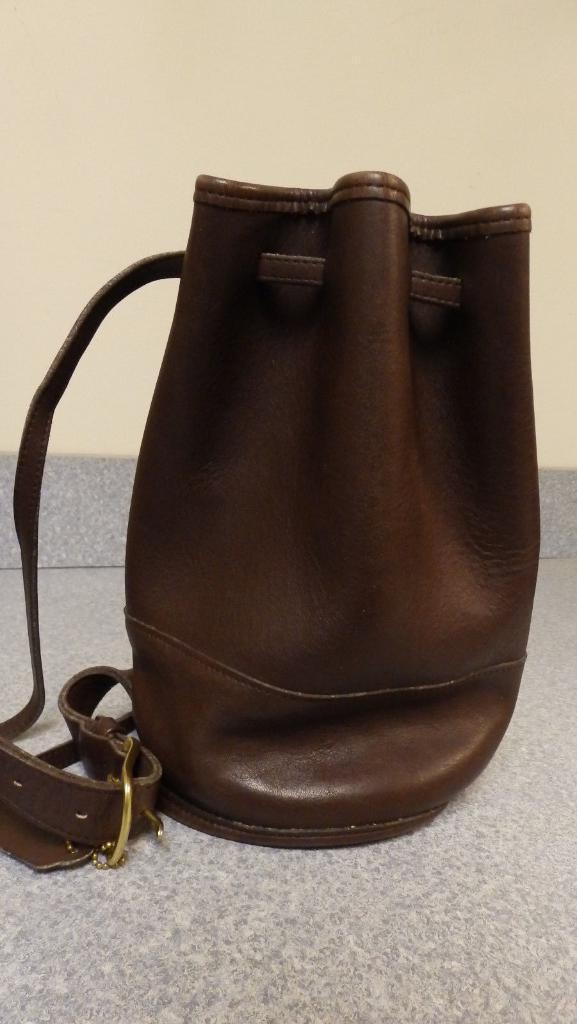Could you give a brief overview of what you see in this image? In this image there is a bag with a belt attached to it which is kept on the floor. In the background there is a wall. 